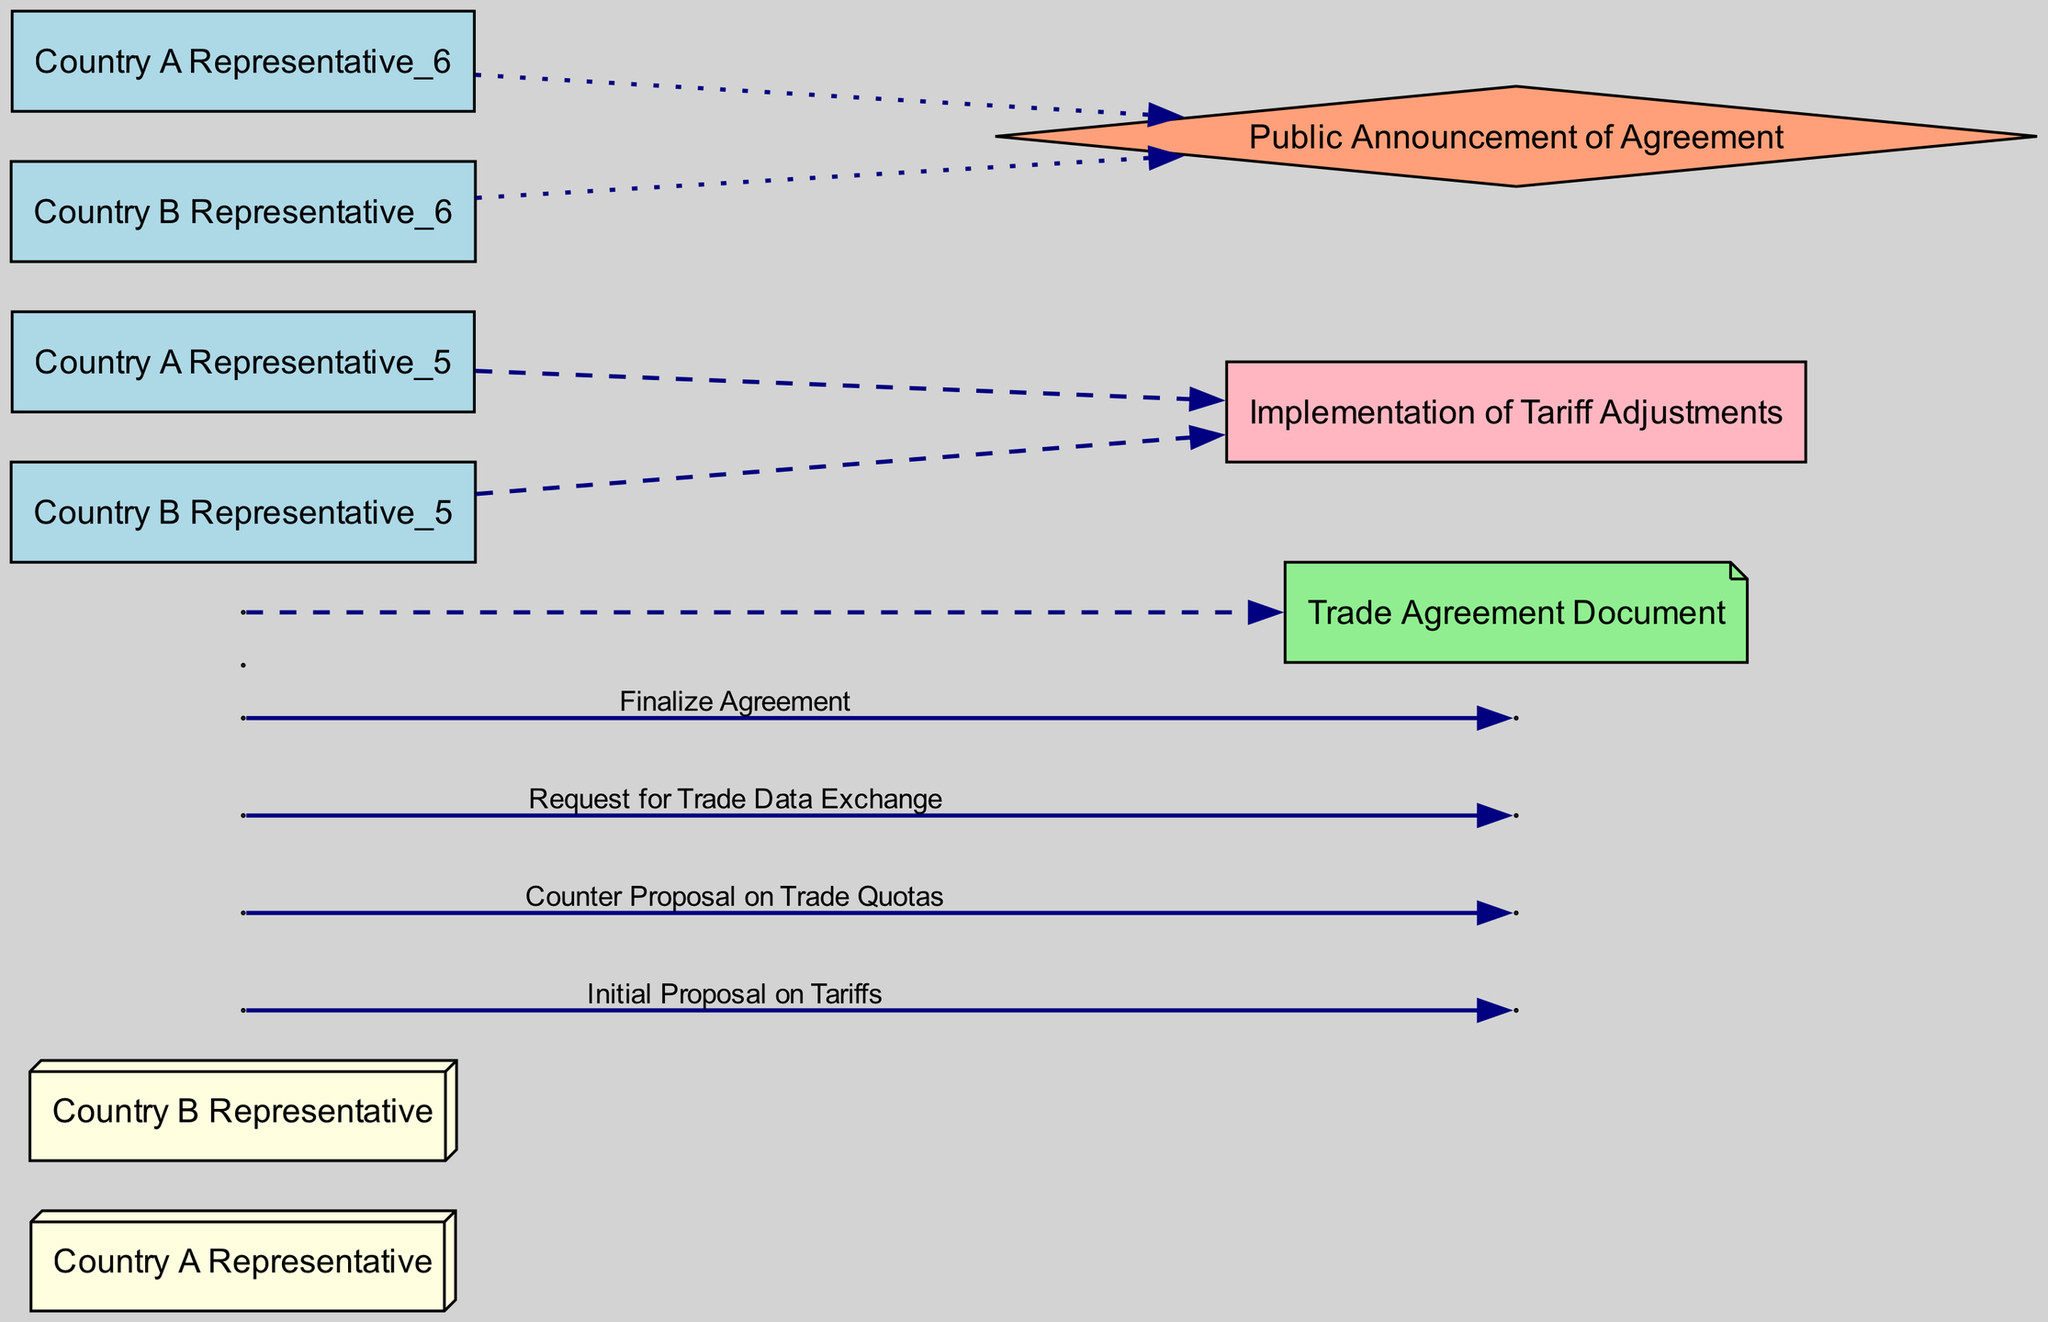What is the first message exchanged between the two representatives? The diagram starts with the "Initial Proposal on Tariffs" being sent from Country A Representative to Country B Representative. This is the first edge connected to the two actors, indicating the beginning of the communication regarding trade issues.
Answer: Initial Proposal on Tariffs How many messages are exchanged in total? By counting all the edges labeled as messages between the two representatives, there are four messages sent in total: "Initial Proposal on Tariffs," "Counter Proposal on Trade Quotas," "Request for Trade Data Exchange," and "Finalize Agreement."
Answer: Four What action follows the message "Counter Proposal on Trade Quotas"? In the sequence, after the message "Counter Proposal on Trade Quotas," the next step is the "Request for Trade Data Exchange." This demonstrates the logical progression of the negotiation process, where one proposal leads to another request for information.
Answer: Request for Trade Data Exchange Which event is triggered after the agreement is finalized? The diagram indicates that after the "Finalize Agreement" message is processed, there is a "Public Announcement of Agreement." This event signifies the conclusion of the negotiation process and the intention to inform the public about the new agreement reached.
Answer: Public Announcement of Agreement Who initiates the sequence of messages? The flow in the diagram starts with the Country A Representative sending the first message, the "Initial Proposal on Tariffs," which sets off the sequence of negotiations. Therefore, Country A is the initiator.
Answer: Country A Representative What is the final artifact produced in the negotiation process? The last item in the sequence is the "Trade Agreement Document." This artifact represents the formal outcome of the negotiations, capturing the agreed terms between both countries.
Answer: Trade Agreement Document How many actors are involved in the negotiation? The diagram clearly illustrates two actors: "Country A Representative" and "Country B Representative." These are the main players involved in the diplomatic negotiations regarding the trade issues.
Answer: Two What is the relationship between "Implementation of Tariff Adjustments" and the representatives? The "Implementation of Tariff Adjustments" is an action that is connected to both representatives. This means that after negotiation and agreement, both countries are involved in putting the new terms regarding tariffs into practice.
Answer: Both Representatives What type of diagram is being described? The structure and components of the diagram, including the actors, messages, actions, and events, categorize it specifically as a "Sequence diagram." This type of diagram is used to represent interactions over time between entities in a process.
Answer: Sequence diagram 